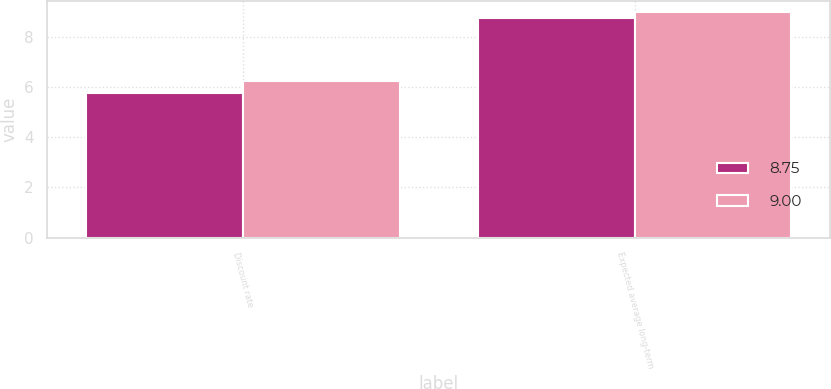Convert chart. <chart><loc_0><loc_0><loc_500><loc_500><stacked_bar_chart><ecel><fcel>Discount rate<fcel>Expected average long-term<nl><fcel>8.75<fcel>5.75<fcel>8.75<nl><fcel>9<fcel>6.25<fcel>9<nl></chart> 